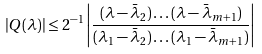Convert formula to latex. <formula><loc_0><loc_0><loc_500><loc_500>| Q ( \lambda ) | \leq 2 ^ { - 1 } \left | \frac { ( \lambda - \bar { \lambda } _ { 2 } ) \dots ( \lambda - \bar { \lambda } _ { m + 1 } ) } { ( \lambda _ { 1 } - \bar { \lambda } _ { 2 } ) \dots ( \lambda _ { 1 } - \bar { \lambda } _ { m + 1 } ) } \right |</formula> 